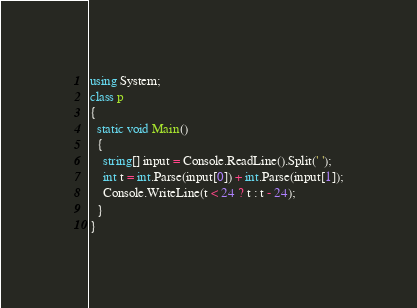Convert code to text. <code><loc_0><loc_0><loc_500><loc_500><_C#_>using System;
class p
{
  static void Main()
  {
    string[] input = Console.ReadLine().Split(' ');
    int t = int.Parse(input[0]) + int.Parse(input[1]);
    Console.WriteLine(t < 24 ? t : t - 24);
  }
}</code> 